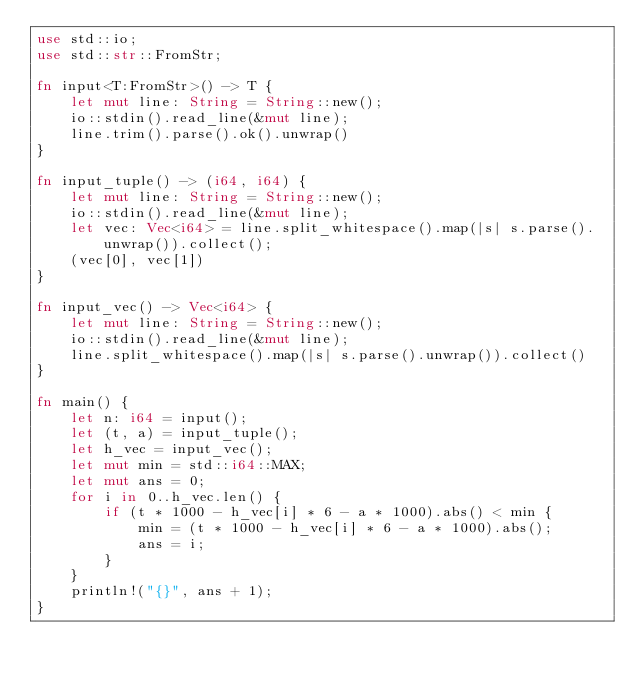<code> <loc_0><loc_0><loc_500><loc_500><_Rust_>use std::io;
use std::str::FromStr;

fn input<T:FromStr>() -> T {
    let mut line: String = String::new();
    io::stdin().read_line(&mut line);
    line.trim().parse().ok().unwrap()
}

fn input_tuple() -> (i64, i64) {
    let mut line: String = String::new();
    io::stdin().read_line(&mut line);
    let vec: Vec<i64> = line.split_whitespace().map(|s| s.parse().unwrap()).collect();
    (vec[0], vec[1])
}

fn input_vec() -> Vec<i64> {
    let mut line: String = String::new();
    io::stdin().read_line(&mut line);
    line.split_whitespace().map(|s| s.parse().unwrap()).collect()
}

fn main() {
    let n: i64 = input();
    let (t, a) = input_tuple();
    let h_vec = input_vec();
    let mut min = std::i64::MAX;
    let mut ans = 0;
    for i in 0..h_vec.len() {
        if (t * 1000 - h_vec[i] * 6 - a * 1000).abs() < min {
            min = (t * 1000 - h_vec[i] * 6 - a * 1000).abs();
            ans = i;
        }
    }
    println!("{}", ans + 1);
}
</code> 